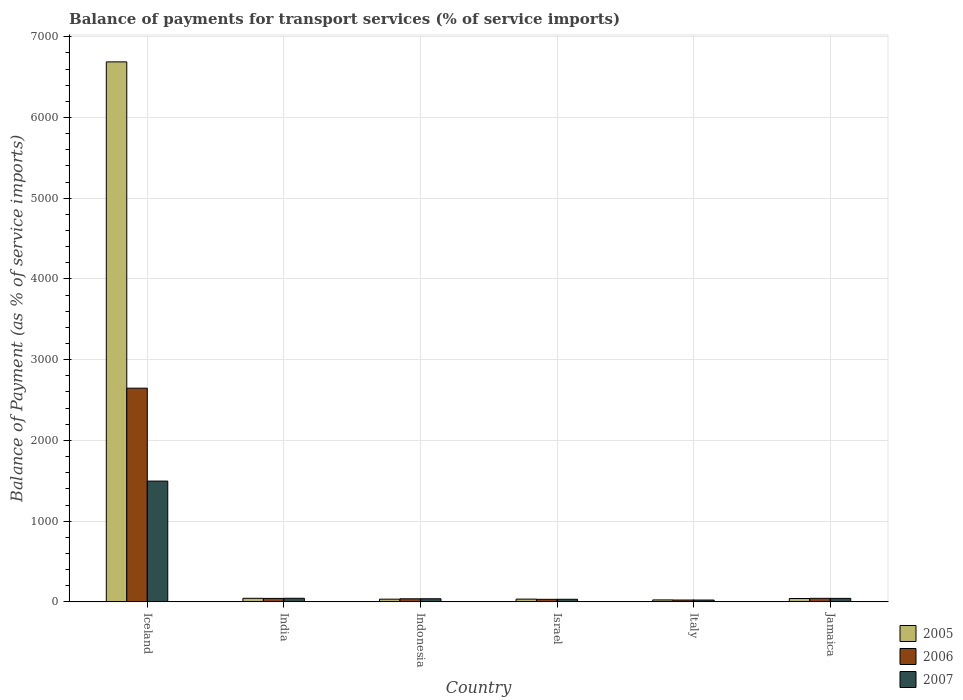How many groups of bars are there?
Make the answer very short. 6. Are the number of bars on each tick of the X-axis equal?
Your answer should be compact. Yes. How many bars are there on the 6th tick from the left?
Make the answer very short. 3. How many bars are there on the 1st tick from the right?
Make the answer very short. 3. What is the label of the 6th group of bars from the left?
Give a very brief answer. Jamaica. In how many cases, is the number of bars for a given country not equal to the number of legend labels?
Offer a very short reply. 0. What is the balance of payments for transport services in 2005 in Italy?
Your answer should be very brief. 24.28. Across all countries, what is the maximum balance of payments for transport services in 2006?
Provide a succinct answer. 2647.13. Across all countries, what is the minimum balance of payments for transport services in 2007?
Your answer should be compact. 22.73. What is the total balance of payments for transport services in 2006 in the graph?
Your answer should be very brief. 2826.33. What is the difference between the balance of payments for transport services in 2007 in Italy and that in Jamaica?
Your answer should be compact. -20.55. What is the difference between the balance of payments for transport services in 2006 in Jamaica and the balance of payments for transport services in 2005 in Israel?
Provide a short and direct response. 9.74. What is the average balance of payments for transport services in 2006 per country?
Ensure brevity in your answer.  471.06. What is the difference between the balance of payments for transport services of/in 2006 and balance of payments for transport services of/in 2007 in Israel?
Ensure brevity in your answer.  -0.72. In how many countries, is the balance of payments for transport services in 2005 greater than 2000 %?
Your answer should be very brief. 1. What is the ratio of the balance of payments for transport services in 2007 in India to that in Jamaica?
Provide a succinct answer. 1.03. Is the balance of payments for transport services in 2007 in India less than that in Israel?
Your answer should be very brief. No. What is the difference between the highest and the second highest balance of payments for transport services in 2007?
Offer a very short reply. 1452.94. What is the difference between the highest and the lowest balance of payments for transport services in 2007?
Make the answer very short. 1473.49. Is the sum of the balance of payments for transport services in 2007 in India and Indonesia greater than the maximum balance of payments for transport services in 2005 across all countries?
Make the answer very short. No. Is it the case that in every country, the sum of the balance of payments for transport services in 2007 and balance of payments for transport services in 2005 is greater than the balance of payments for transport services in 2006?
Offer a terse response. Yes. How many countries are there in the graph?
Make the answer very short. 6. What is the difference between two consecutive major ticks on the Y-axis?
Give a very brief answer. 1000. Does the graph contain grids?
Your answer should be compact. Yes. Where does the legend appear in the graph?
Make the answer very short. Bottom right. How are the legend labels stacked?
Provide a succinct answer. Vertical. What is the title of the graph?
Provide a short and direct response. Balance of payments for transport services (% of service imports). What is the label or title of the X-axis?
Give a very brief answer. Country. What is the label or title of the Y-axis?
Offer a very short reply. Balance of Payment (as % of service imports). What is the Balance of Payment (as % of service imports) of 2005 in Iceland?
Keep it short and to the point. 6689.16. What is the Balance of Payment (as % of service imports) of 2006 in Iceland?
Your response must be concise. 2647.13. What is the Balance of Payment (as % of service imports) of 2007 in Iceland?
Keep it short and to the point. 1496.22. What is the Balance of Payment (as % of service imports) in 2005 in India?
Provide a short and direct response. 44.28. What is the Balance of Payment (as % of service imports) of 2006 in India?
Give a very brief answer. 43. What is the Balance of Payment (as % of service imports) of 2007 in India?
Ensure brevity in your answer.  44.56. What is the Balance of Payment (as % of service imports) in 2005 in Indonesia?
Provide a succinct answer. 33.57. What is the Balance of Payment (as % of service imports) in 2006 in Indonesia?
Your answer should be compact. 37.94. What is the Balance of Payment (as % of service imports) in 2007 in Indonesia?
Offer a very short reply. 38.66. What is the Balance of Payment (as % of service imports) of 2005 in Israel?
Make the answer very short. 34.07. What is the Balance of Payment (as % of service imports) in 2006 in Israel?
Offer a very short reply. 31.55. What is the Balance of Payment (as % of service imports) of 2007 in Israel?
Provide a succinct answer. 32.27. What is the Balance of Payment (as % of service imports) in 2005 in Italy?
Keep it short and to the point. 24.28. What is the Balance of Payment (as % of service imports) of 2006 in Italy?
Make the answer very short. 22.91. What is the Balance of Payment (as % of service imports) in 2007 in Italy?
Your answer should be compact. 22.73. What is the Balance of Payment (as % of service imports) of 2005 in Jamaica?
Give a very brief answer. 41.68. What is the Balance of Payment (as % of service imports) of 2006 in Jamaica?
Make the answer very short. 43.81. What is the Balance of Payment (as % of service imports) of 2007 in Jamaica?
Offer a very short reply. 43.28. Across all countries, what is the maximum Balance of Payment (as % of service imports) in 2005?
Provide a short and direct response. 6689.16. Across all countries, what is the maximum Balance of Payment (as % of service imports) of 2006?
Ensure brevity in your answer.  2647.13. Across all countries, what is the maximum Balance of Payment (as % of service imports) of 2007?
Your response must be concise. 1496.22. Across all countries, what is the minimum Balance of Payment (as % of service imports) in 2005?
Your answer should be very brief. 24.28. Across all countries, what is the minimum Balance of Payment (as % of service imports) of 2006?
Provide a succinct answer. 22.91. Across all countries, what is the minimum Balance of Payment (as % of service imports) of 2007?
Make the answer very short. 22.73. What is the total Balance of Payment (as % of service imports) of 2005 in the graph?
Your answer should be compact. 6867.03. What is the total Balance of Payment (as % of service imports) in 2006 in the graph?
Provide a succinct answer. 2826.33. What is the total Balance of Payment (as % of service imports) in 2007 in the graph?
Offer a terse response. 1677.71. What is the difference between the Balance of Payment (as % of service imports) of 2005 in Iceland and that in India?
Provide a succinct answer. 6644.87. What is the difference between the Balance of Payment (as % of service imports) of 2006 in Iceland and that in India?
Offer a terse response. 2604.13. What is the difference between the Balance of Payment (as % of service imports) in 2007 in Iceland and that in India?
Offer a terse response. 1451.67. What is the difference between the Balance of Payment (as % of service imports) of 2005 in Iceland and that in Indonesia?
Provide a short and direct response. 6655.59. What is the difference between the Balance of Payment (as % of service imports) of 2006 in Iceland and that in Indonesia?
Your answer should be compact. 2609.18. What is the difference between the Balance of Payment (as % of service imports) of 2007 in Iceland and that in Indonesia?
Your response must be concise. 1457.57. What is the difference between the Balance of Payment (as % of service imports) in 2005 in Iceland and that in Israel?
Offer a very short reply. 6655.08. What is the difference between the Balance of Payment (as % of service imports) of 2006 in Iceland and that in Israel?
Your response must be concise. 2615.58. What is the difference between the Balance of Payment (as % of service imports) of 2007 in Iceland and that in Israel?
Keep it short and to the point. 1463.95. What is the difference between the Balance of Payment (as % of service imports) in 2005 in Iceland and that in Italy?
Give a very brief answer. 6664.88. What is the difference between the Balance of Payment (as % of service imports) in 2006 in Iceland and that in Italy?
Offer a very short reply. 2624.22. What is the difference between the Balance of Payment (as % of service imports) of 2007 in Iceland and that in Italy?
Offer a terse response. 1473.49. What is the difference between the Balance of Payment (as % of service imports) of 2005 in Iceland and that in Jamaica?
Ensure brevity in your answer.  6647.47. What is the difference between the Balance of Payment (as % of service imports) in 2006 in Iceland and that in Jamaica?
Offer a very short reply. 2603.32. What is the difference between the Balance of Payment (as % of service imports) of 2007 in Iceland and that in Jamaica?
Keep it short and to the point. 1452.94. What is the difference between the Balance of Payment (as % of service imports) of 2005 in India and that in Indonesia?
Provide a short and direct response. 10.72. What is the difference between the Balance of Payment (as % of service imports) in 2006 in India and that in Indonesia?
Ensure brevity in your answer.  5.05. What is the difference between the Balance of Payment (as % of service imports) of 2007 in India and that in Indonesia?
Give a very brief answer. 5.9. What is the difference between the Balance of Payment (as % of service imports) in 2005 in India and that in Israel?
Keep it short and to the point. 10.21. What is the difference between the Balance of Payment (as % of service imports) of 2006 in India and that in Israel?
Provide a short and direct response. 11.45. What is the difference between the Balance of Payment (as % of service imports) in 2007 in India and that in Israel?
Your answer should be compact. 12.29. What is the difference between the Balance of Payment (as % of service imports) of 2005 in India and that in Italy?
Your response must be concise. 20. What is the difference between the Balance of Payment (as % of service imports) of 2006 in India and that in Italy?
Keep it short and to the point. 20.08. What is the difference between the Balance of Payment (as % of service imports) of 2007 in India and that in Italy?
Your response must be concise. 21.83. What is the difference between the Balance of Payment (as % of service imports) in 2005 in India and that in Jamaica?
Provide a succinct answer. 2.6. What is the difference between the Balance of Payment (as % of service imports) in 2006 in India and that in Jamaica?
Your response must be concise. -0.81. What is the difference between the Balance of Payment (as % of service imports) of 2007 in India and that in Jamaica?
Your response must be concise. 1.27. What is the difference between the Balance of Payment (as % of service imports) of 2005 in Indonesia and that in Israel?
Your response must be concise. -0.5. What is the difference between the Balance of Payment (as % of service imports) in 2006 in Indonesia and that in Israel?
Your answer should be very brief. 6.4. What is the difference between the Balance of Payment (as % of service imports) of 2007 in Indonesia and that in Israel?
Offer a terse response. 6.39. What is the difference between the Balance of Payment (as % of service imports) in 2005 in Indonesia and that in Italy?
Your answer should be very brief. 9.29. What is the difference between the Balance of Payment (as % of service imports) in 2006 in Indonesia and that in Italy?
Your response must be concise. 15.03. What is the difference between the Balance of Payment (as % of service imports) of 2007 in Indonesia and that in Italy?
Provide a short and direct response. 15.93. What is the difference between the Balance of Payment (as % of service imports) of 2005 in Indonesia and that in Jamaica?
Provide a succinct answer. -8.11. What is the difference between the Balance of Payment (as % of service imports) in 2006 in Indonesia and that in Jamaica?
Provide a succinct answer. -5.87. What is the difference between the Balance of Payment (as % of service imports) in 2007 in Indonesia and that in Jamaica?
Offer a terse response. -4.63. What is the difference between the Balance of Payment (as % of service imports) in 2005 in Israel and that in Italy?
Provide a short and direct response. 9.79. What is the difference between the Balance of Payment (as % of service imports) in 2006 in Israel and that in Italy?
Your answer should be compact. 8.63. What is the difference between the Balance of Payment (as % of service imports) in 2007 in Israel and that in Italy?
Keep it short and to the point. 9.54. What is the difference between the Balance of Payment (as % of service imports) of 2005 in Israel and that in Jamaica?
Ensure brevity in your answer.  -7.61. What is the difference between the Balance of Payment (as % of service imports) of 2006 in Israel and that in Jamaica?
Provide a short and direct response. -12.26. What is the difference between the Balance of Payment (as % of service imports) of 2007 in Israel and that in Jamaica?
Offer a terse response. -11.01. What is the difference between the Balance of Payment (as % of service imports) of 2005 in Italy and that in Jamaica?
Offer a very short reply. -17.4. What is the difference between the Balance of Payment (as % of service imports) of 2006 in Italy and that in Jamaica?
Your response must be concise. -20.9. What is the difference between the Balance of Payment (as % of service imports) of 2007 in Italy and that in Jamaica?
Your response must be concise. -20.55. What is the difference between the Balance of Payment (as % of service imports) of 2005 in Iceland and the Balance of Payment (as % of service imports) of 2006 in India?
Your response must be concise. 6646.16. What is the difference between the Balance of Payment (as % of service imports) in 2005 in Iceland and the Balance of Payment (as % of service imports) in 2007 in India?
Your answer should be very brief. 6644.6. What is the difference between the Balance of Payment (as % of service imports) of 2006 in Iceland and the Balance of Payment (as % of service imports) of 2007 in India?
Make the answer very short. 2602.57. What is the difference between the Balance of Payment (as % of service imports) in 2005 in Iceland and the Balance of Payment (as % of service imports) in 2006 in Indonesia?
Make the answer very short. 6651.21. What is the difference between the Balance of Payment (as % of service imports) of 2005 in Iceland and the Balance of Payment (as % of service imports) of 2007 in Indonesia?
Ensure brevity in your answer.  6650.5. What is the difference between the Balance of Payment (as % of service imports) in 2006 in Iceland and the Balance of Payment (as % of service imports) in 2007 in Indonesia?
Offer a very short reply. 2608.47. What is the difference between the Balance of Payment (as % of service imports) in 2005 in Iceland and the Balance of Payment (as % of service imports) in 2006 in Israel?
Your answer should be compact. 6657.61. What is the difference between the Balance of Payment (as % of service imports) in 2005 in Iceland and the Balance of Payment (as % of service imports) in 2007 in Israel?
Ensure brevity in your answer.  6656.89. What is the difference between the Balance of Payment (as % of service imports) in 2006 in Iceland and the Balance of Payment (as % of service imports) in 2007 in Israel?
Offer a terse response. 2614.86. What is the difference between the Balance of Payment (as % of service imports) of 2005 in Iceland and the Balance of Payment (as % of service imports) of 2006 in Italy?
Your answer should be very brief. 6666.24. What is the difference between the Balance of Payment (as % of service imports) of 2005 in Iceland and the Balance of Payment (as % of service imports) of 2007 in Italy?
Your response must be concise. 6666.43. What is the difference between the Balance of Payment (as % of service imports) in 2006 in Iceland and the Balance of Payment (as % of service imports) in 2007 in Italy?
Provide a succinct answer. 2624.4. What is the difference between the Balance of Payment (as % of service imports) in 2005 in Iceland and the Balance of Payment (as % of service imports) in 2006 in Jamaica?
Your response must be concise. 6645.35. What is the difference between the Balance of Payment (as % of service imports) of 2005 in Iceland and the Balance of Payment (as % of service imports) of 2007 in Jamaica?
Your answer should be compact. 6645.87. What is the difference between the Balance of Payment (as % of service imports) in 2006 in Iceland and the Balance of Payment (as % of service imports) in 2007 in Jamaica?
Your response must be concise. 2603.85. What is the difference between the Balance of Payment (as % of service imports) in 2005 in India and the Balance of Payment (as % of service imports) in 2006 in Indonesia?
Provide a short and direct response. 6.34. What is the difference between the Balance of Payment (as % of service imports) in 2005 in India and the Balance of Payment (as % of service imports) in 2007 in Indonesia?
Your answer should be compact. 5.63. What is the difference between the Balance of Payment (as % of service imports) in 2006 in India and the Balance of Payment (as % of service imports) in 2007 in Indonesia?
Your answer should be very brief. 4.34. What is the difference between the Balance of Payment (as % of service imports) of 2005 in India and the Balance of Payment (as % of service imports) of 2006 in Israel?
Keep it short and to the point. 12.74. What is the difference between the Balance of Payment (as % of service imports) in 2005 in India and the Balance of Payment (as % of service imports) in 2007 in Israel?
Keep it short and to the point. 12.01. What is the difference between the Balance of Payment (as % of service imports) of 2006 in India and the Balance of Payment (as % of service imports) of 2007 in Israel?
Your answer should be compact. 10.73. What is the difference between the Balance of Payment (as % of service imports) of 2005 in India and the Balance of Payment (as % of service imports) of 2006 in Italy?
Offer a very short reply. 21.37. What is the difference between the Balance of Payment (as % of service imports) in 2005 in India and the Balance of Payment (as % of service imports) in 2007 in Italy?
Your response must be concise. 21.55. What is the difference between the Balance of Payment (as % of service imports) in 2006 in India and the Balance of Payment (as % of service imports) in 2007 in Italy?
Provide a short and direct response. 20.27. What is the difference between the Balance of Payment (as % of service imports) of 2005 in India and the Balance of Payment (as % of service imports) of 2006 in Jamaica?
Your response must be concise. 0.47. What is the difference between the Balance of Payment (as % of service imports) in 2006 in India and the Balance of Payment (as % of service imports) in 2007 in Jamaica?
Your answer should be very brief. -0.29. What is the difference between the Balance of Payment (as % of service imports) of 2005 in Indonesia and the Balance of Payment (as % of service imports) of 2006 in Israel?
Your response must be concise. 2.02. What is the difference between the Balance of Payment (as % of service imports) in 2005 in Indonesia and the Balance of Payment (as % of service imports) in 2007 in Israel?
Give a very brief answer. 1.3. What is the difference between the Balance of Payment (as % of service imports) of 2006 in Indonesia and the Balance of Payment (as % of service imports) of 2007 in Israel?
Offer a terse response. 5.67. What is the difference between the Balance of Payment (as % of service imports) of 2005 in Indonesia and the Balance of Payment (as % of service imports) of 2006 in Italy?
Make the answer very short. 10.65. What is the difference between the Balance of Payment (as % of service imports) in 2005 in Indonesia and the Balance of Payment (as % of service imports) in 2007 in Italy?
Keep it short and to the point. 10.84. What is the difference between the Balance of Payment (as % of service imports) in 2006 in Indonesia and the Balance of Payment (as % of service imports) in 2007 in Italy?
Ensure brevity in your answer.  15.21. What is the difference between the Balance of Payment (as % of service imports) of 2005 in Indonesia and the Balance of Payment (as % of service imports) of 2006 in Jamaica?
Keep it short and to the point. -10.24. What is the difference between the Balance of Payment (as % of service imports) in 2005 in Indonesia and the Balance of Payment (as % of service imports) in 2007 in Jamaica?
Your response must be concise. -9.72. What is the difference between the Balance of Payment (as % of service imports) in 2006 in Indonesia and the Balance of Payment (as % of service imports) in 2007 in Jamaica?
Make the answer very short. -5.34. What is the difference between the Balance of Payment (as % of service imports) of 2005 in Israel and the Balance of Payment (as % of service imports) of 2006 in Italy?
Give a very brief answer. 11.16. What is the difference between the Balance of Payment (as % of service imports) of 2005 in Israel and the Balance of Payment (as % of service imports) of 2007 in Italy?
Offer a terse response. 11.34. What is the difference between the Balance of Payment (as % of service imports) in 2006 in Israel and the Balance of Payment (as % of service imports) in 2007 in Italy?
Provide a short and direct response. 8.81. What is the difference between the Balance of Payment (as % of service imports) of 2005 in Israel and the Balance of Payment (as % of service imports) of 2006 in Jamaica?
Offer a terse response. -9.74. What is the difference between the Balance of Payment (as % of service imports) of 2005 in Israel and the Balance of Payment (as % of service imports) of 2007 in Jamaica?
Provide a short and direct response. -9.21. What is the difference between the Balance of Payment (as % of service imports) in 2006 in Israel and the Balance of Payment (as % of service imports) in 2007 in Jamaica?
Keep it short and to the point. -11.74. What is the difference between the Balance of Payment (as % of service imports) of 2005 in Italy and the Balance of Payment (as % of service imports) of 2006 in Jamaica?
Your response must be concise. -19.53. What is the difference between the Balance of Payment (as % of service imports) in 2005 in Italy and the Balance of Payment (as % of service imports) in 2007 in Jamaica?
Offer a very short reply. -19. What is the difference between the Balance of Payment (as % of service imports) of 2006 in Italy and the Balance of Payment (as % of service imports) of 2007 in Jamaica?
Provide a short and direct response. -20.37. What is the average Balance of Payment (as % of service imports) in 2005 per country?
Provide a short and direct response. 1144.51. What is the average Balance of Payment (as % of service imports) of 2006 per country?
Ensure brevity in your answer.  471.06. What is the average Balance of Payment (as % of service imports) in 2007 per country?
Provide a short and direct response. 279.62. What is the difference between the Balance of Payment (as % of service imports) of 2005 and Balance of Payment (as % of service imports) of 2006 in Iceland?
Provide a succinct answer. 4042.03. What is the difference between the Balance of Payment (as % of service imports) in 2005 and Balance of Payment (as % of service imports) in 2007 in Iceland?
Your response must be concise. 5192.93. What is the difference between the Balance of Payment (as % of service imports) in 2006 and Balance of Payment (as % of service imports) in 2007 in Iceland?
Your answer should be compact. 1150.91. What is the difference between the Balance of Payment (as % of service imports) in 2005 and Balance of Payment (as % of service imports) in 2006 in India?
Offer a very short reply. 1.29. What is the difference between the Balance of Payment (as % of service imports) in 2005 and Balance of Payment (as % of service imports) in 2007 in India?
Your response must be concise. -0.27. What is the difference between the Balance of Payment (as % of service imports) in 2006 and Balance of Payment (as % of service imports) in 2007 in India?
Offer a terse response. -1.56. What is the difference between the Balance of Payment (as % of service imports) in 2005 and Balance of Payment (as % of service imports) in 2006 in Indonesia?
Provide a succinct answer. -4.38. What is the difference between the Balance of Payment (as % of service imports) in 2005 and Balance of Payment (as % of service imports) in 2007 in Indonesia?
Your answer should be compact. -5.09. What is the difference between the Balance of Payment (as % of service imports) of 2006 and Balance of Payment (as % of service imports) of 2007 in Indonesia?
Provide a short and direct response. -0.71. What is the difference between the Balance of Payment (as % of service imports) in 2005 and Balance of Payment (as % of service imports) in 2006 in Israel?
Provide a short and direct response. 2.53. What is the difference between the Balance of Payment (as % of service imports) in 2005 and Balance of Payment (as % of service imports) in 2007 in Israel?
Your answer should be very brief. 1.8. What is the difference between the Balance of Payment (as % of service imports) of 2006 and Balance of Payment (as % of service imports) of 2007 in Israel?
Make the answer very short. -0.72. What is the difference between the Balance of Payment (as % of service imports) of 2005 and Balance of Payment (as % of service imports) of 2006 in Italy?
Provide a succinct answer. 1.37. What is the difference between the Balance of Payment (as % of service imports) in 2005 and Balance of Payment (as % of service imports) in 2007 in Italy?
Your response must be concise. 1.55. What is the difference between the Balance of Payment (as % of service imports) in 2006 and Balance of Payment (as % of service imports) in 2007 in Italy?
Offer a very short reply. 0.18. What is the difference between the Balance of Payment (as % of service imports) of 2005 and Balance of Payment (as % of service imports) of 2006 in Jamaica?
Offer a very short reply. -2.13. What is the difference between the Balance of Payment (as % of service imports) in 2005 and Balance of Payment (as % of service imports) in 2007 in Jamaica?
Make the answer very short. -1.6. What is the difference between the Balance of Payment (as % of service imports) in 2006 and Balance of Payment (as % of service imports) in 2007 in Jamaica?
Offer a terse response. 0.53. What is the ratio of the Balance of Payment (as % of service imports) in 2005 in Iceland to that in India?
Ensure brevity in your answer.  151.06. What is the ratio of the Balance of Payment (as % of service imports) in 2006 in Iceland to that in India?
Your answer should be compact. 61.57. What is the ratio of the Balance of Payment (as % of service imports) of 2007 in Iceland to that in India?
Keep it short and to the point. 33.58. What is the ratio of the Balance of Payment (as % of service imports) of 2005 in Iceland to that in Indonesia?
Your answer should be compact. 199.28. What is the ratio of the Balance of Payment (as % of service imports) of 2006 in Iceland to that in Indonesia?
Provide a short and direct response. 69.77. What is the ratio of the Balance of Payment (as % of service imports) in 2007 in Iceland to that in Indonesia?
Your answer should be very brief. 38.71. What is the ratio of the Balance of Payment (as % of service imports) of 2005 in Iceland to that in Israel?
Offer a terse response. 196.33. What is the ratio of the Balance of Payment (as % of service imports) in 2006 in Iceland to that in Israel?
Keep it short and to the point. 83.92. What is the ratio of the Balance of Payment (as % of service imports) in 2007 in Iceland to that in Israel?
Your answer should be very brief. 46.37. What is the ratio of the Balance of Payment (as % of service imports) in 2005 in Iceland to that in Italy?
Provide a succinct answer. 275.52. What is the ratio of the Balance of Payment (as % of service imports) of 2006 in Iceland to that in Italy?
Provide a succinct answer. 115.53. What is the ratio of the Balance of Payment (as % of service imports) in 2007 in Iceland to that in Italy?
Your answer should be very brief. 65.83. What is the ratio of the Balance of Payment (as % of service imports) in 2005 in Iceland to that in Jamaica?
Provide a short and direct response. 160.49. What is the ratio of the Balance of Payment (as % of service imports) in 2006 in Iceland to that in Jamaica?
Provide a short and direct response. 60.42. What is the ratio of the Balance of Payment (as % of service imports) in 2007 in Iceland to that in Jamaica?
Your answer should be very brief. 34.57. What is the ratio of the Balance of Payment (as % of service imports) in 2005 in India to that in Indonesia?
Ensure brevity in your answer.  1.32. What is the ratio of the Balance of Payment (as % of service imports) of 2006 in India to that in Indonesia?
Make the answer very short. 1.13. What is the ratio of the Balance of Payment (as % of service imports) of 2007 in India to that in Indonesia?
Ensure brevity in your answer.  1.15. What is the ratio of the Balance of Payment (as % of service imports) of 2005 in India to that in Israel?
Make the answer very short. 1.3. What is the ratio of the Balance of Payment (as % of service imports) in 2006 in India to that in Israel?
Provide a short and direct response. 1.36. What is the ratio of the Balance of Payment (as % of service imports) in 2007 in India to that in Israel?
Give a very brief answer. 1.38. What is the ratio of the Balance of Payment (as % of service imports) in 2005 in India to that in Italy?
Offer a terse response. 1.82. What is the ratio of the Balance of Payment (as % of service imports) in 2006 in India to that in Italy?
Your response must be concise. 1.88. What is the ratio of the Balance of Payment (as % of service imports) in 2007 in India to that in Italy?
Offer a terse response. 1.96. What is the ratio of the Balance of Payment (as % of service imports) in 2005 in India to that in Jamaica?
Offer a very short reply. 1.06. What is the ratio of the Balance of Payment (as % of service imports) in 2006 in India to that in Jamaica?
Keep it short and to the point. 0.98. What is the ratio of the Balance of Payment (as % of service imports) in 2007 in India to that in Jamaica?
Your answer should be very brief. 1.03. What is the ratio of the Balance of Payment (as % of service imports) in 2005 in Indonesia to that in Israel?
Your answer should be compact. 0.99. What is the ratio of the Balance of Payment (as % of service imports) of 2006 in Indonesia to that in Israel?
Make the answer very short. 1.2. What is the ratio of the Balance of Payment (as % of service imports) of 2007 in Indonesia to that in Israel?
Offer a very short reply. 1.2. What is the ratio of the Balance of Payment (as % of service imports) of 2005 in Indonesia to that in Italy?
Make the answer very short. 1.38. What is the ratio of the Balance of Payment (as % of service imports) of 2006 in Indonesia to that in Italy?
Your answer should be compact. 1.66. What is the ratio of the Balance of Payment (as % of service imports) in 2007 in Indonesia to that in Italy?
Keep it short and to the point. 1.7. What is the ratio of the Balance of Payment (as % of service imports) in 2005 in Indonesia to that in Jamaica?
Make the answer very short. 0.81. What is the ratio of the Balance of Payment (as % of service imports) of 2006 in Indonesia to that in Jamaica?
Your answer should be very brief. 0.87. What is the ratio of the Balance of Payment (as % of service imports) in 2007 in Indonesia to that in Jamaica?
Provide a succinct answer. 0.89. What is the ratio of the Balance of Payment (as % of service imports) in 2005 in Israel to that in Italy?
Make the answer very short. 1.4. What is the ratio of the Balance of Payment (as % of service imports) of 2006 in Israel to that in Italy?
Provide a succinct answer. 1.38. What is the ratio of the Balance of Payment (as % of service imports) of 2007 in Israel to that in Italy?
Make the answer very short. 1.42. What is the ratio of the Balance of Payment (as % of service imports) of 2005 in Israel to that in Jamaica?
Your response must be concise. 0.82. What is the ratio of the Balance of Payment (as % of service imports) of 2006 in Israel to that in Jamaica?
Offer a terse response. 0.72. What is the ratio of the Balance of Payment (as % of service imports) in 2007 in Israel to that in Jamaica?
Your response must be concise. 0.75. What is the ratio of the Balance of Payment (as % of service imports) of 2005 in Italy to that in Jamaica?
Your answer should be compact. 0.58. What is the ratio of the Balance of Payment (as % of service imports) in 2006 in Italy to that in Jamaica?
Provide a succinct answer. 0.52. What is the ratio of the Balance of Payment (as % of service imports) of 2007 in Italy to that in Jamaica?
Give a very brief answer. 0.53. What is the difference between the highest and the second highest Balance of Payment (as % of service imports) in 2005?
Give a very brief answer. 6644.87. What is the difference between the highest and the second highest Balance of Payment (as % of service imports) of 2006?
Make the answer very short. 2603.32. What is the difference between the highest and the second highest Balance of Payment (as % of service imports) of 2007?
Provide a succinct answer. 1451.67. What is the difference between the highest and the lowest Balance of Payment (as % of service imports) of 2005?
Your response must be concise. 6664.88. What is the difference between the highest and the lowest Balance of Payment (as % of service imports) in 2006?
Make the answer very short. 2624.22. What is the difference between the highest and the lowest Balance of Payment (as % of service imports) in 2007?
Provide a succinct answer. 1473.49. 